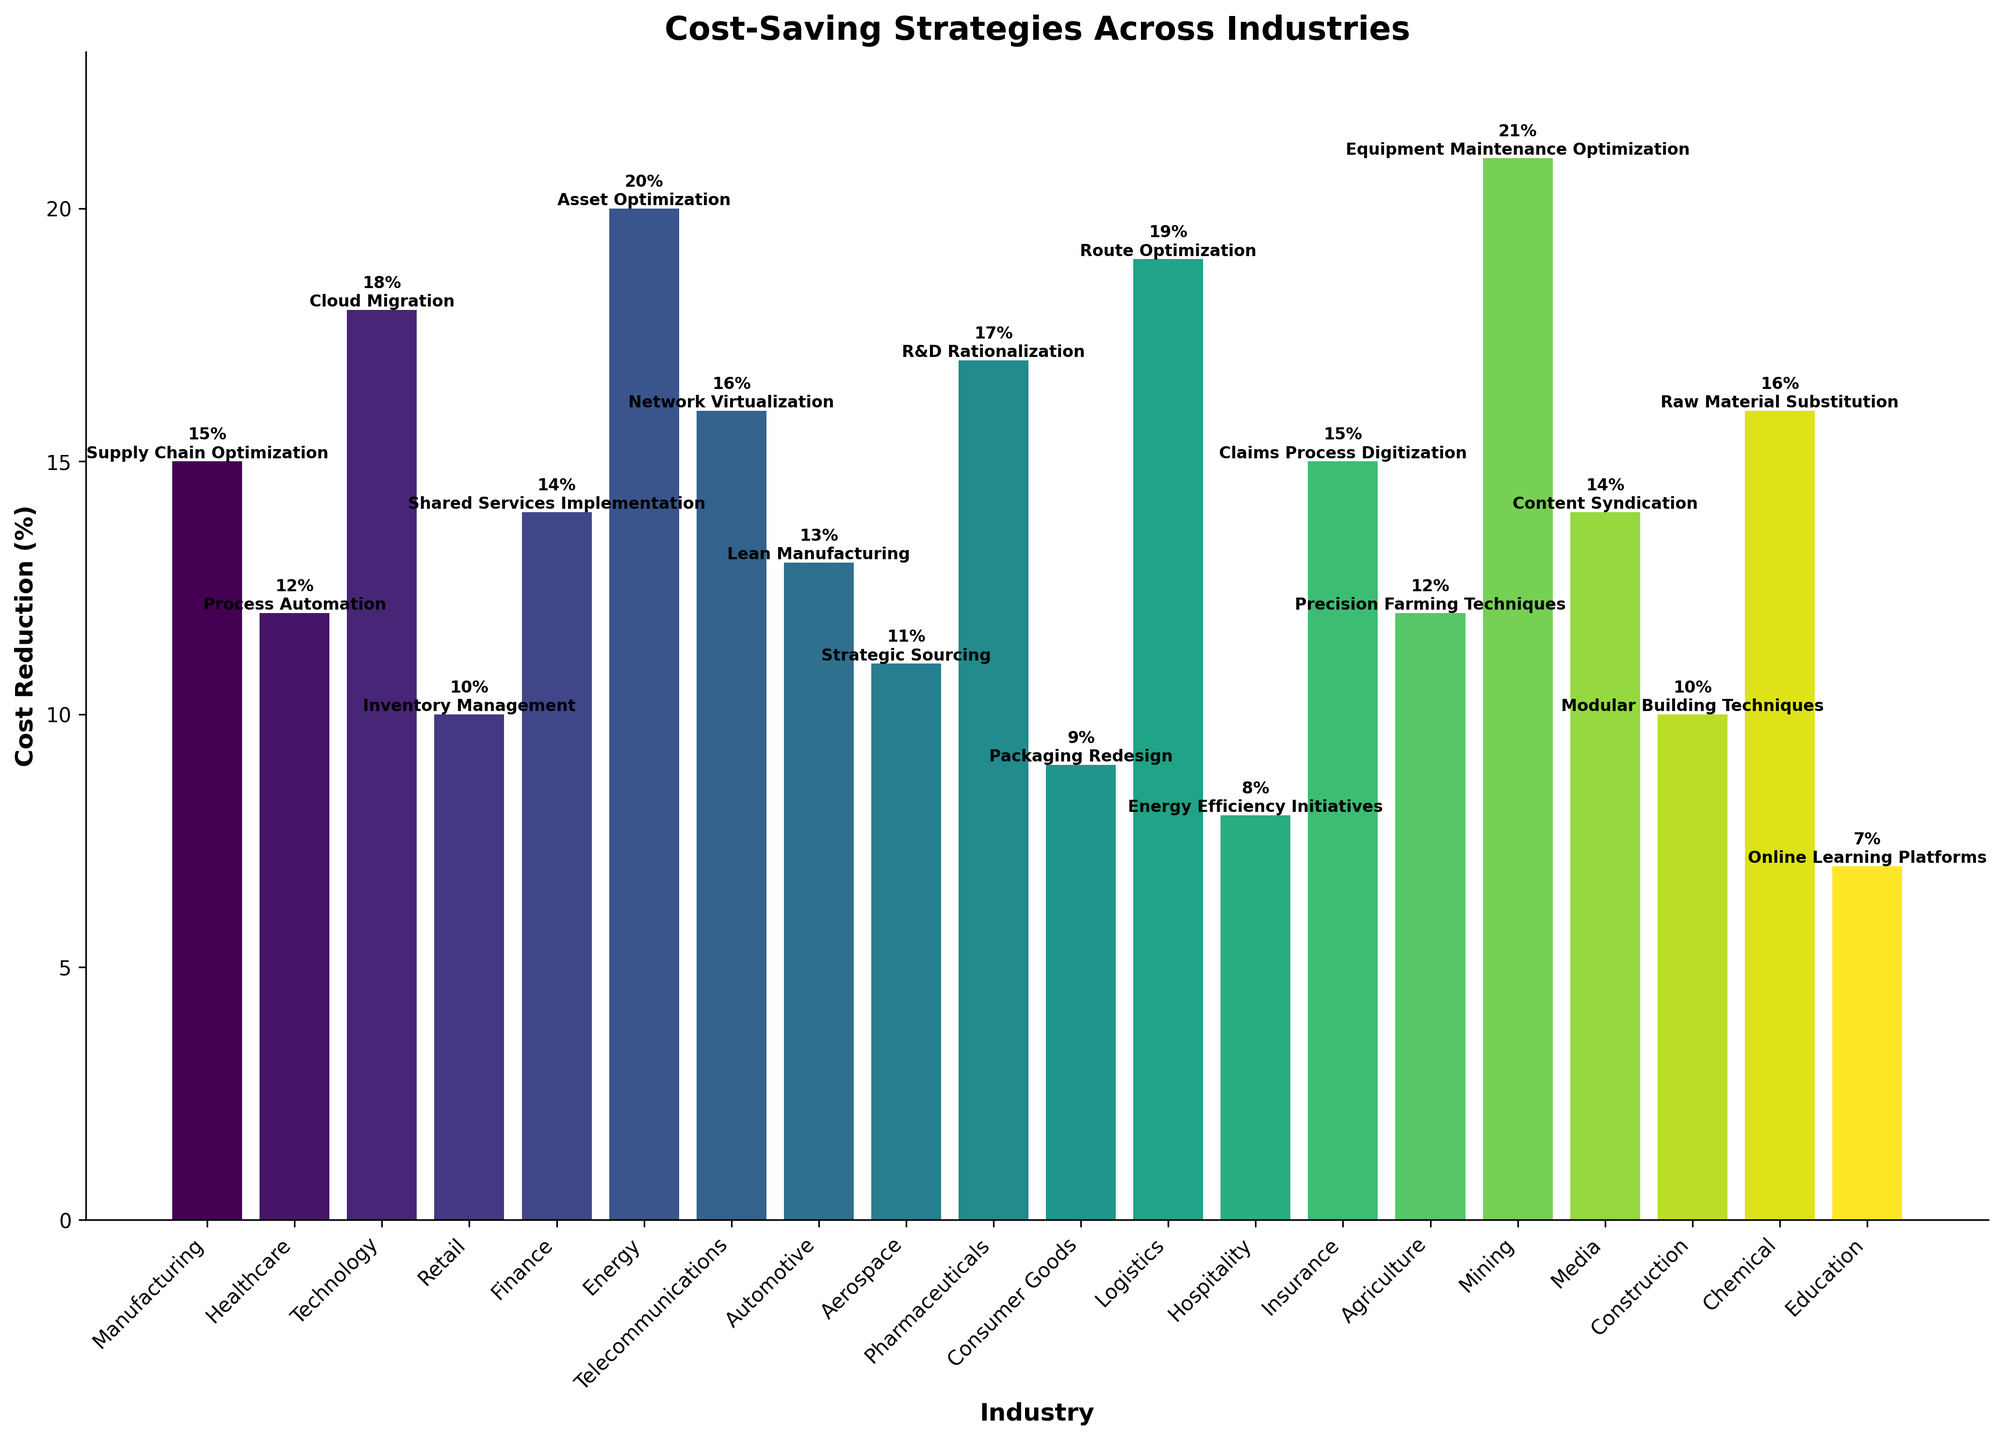What's the highest cost reduction achieved and which industry implemented it? Scan the heights of the bars and identify the tallest one; the tallest bar represents the highest cost reduction. Correspondingly, identify the industry linked to this bar.
Answer: Mining, 21% Which industry has the lowest cost reduction and what strategy did it implement? Identify the shortest bar and its corresponding label. The strategy is indicated by the text on the bar.
Answer: Education, Online Learning Platforms By how much does the cost reduction in Technology exceed the cost reduction in Retail? Locate the bars representing Technology and Retail, note their heights (18% and 10% respectively), and subtract the lower from the higher value.
Answer: 8% Are there any industries that achieved the same percentage cost reduction? If so, which ones? Scan the heights of the bars to identify equal heights and then list the corresponding industries.
Answer: Manufacturing and Insurance both achieved 15%, Healthcare and Agriculture both achieved 12%, Telecommunications and Chemical both achieved 16%, Finance and Media both achieved 14% Which industries saw a cost reduction greater than 15%? Identify all bars taller than the one representing 15% cost reduction and list the corresponding industries.
Answer: Technology, Energy, Telecommunications, Pharmaceuticals, Logistics, Mining What is the total cost reduction percentage if Manufacturing, Finance, and Automotive were combined? Note the cost reductions for these industries (15%, 14%, and 13% respectively) and sum these values.
Answer: 42% How many industries achieved a cost reduction below 10%? Count the number of bars that do not reach the 10% height mark.
Answer: 2 What strategy did the Energy industry implement and what was its cost reduction percentage? Identify the bar labeled 'Energy' and read its height and text description.
Answer: Asset Optimization, 20% What is the average cost reduction percentage across all industries shown? Sum all the cost reduction percentages and divide by the number of industries. (15+12+18+10+14+20+16+13+11+17+9+19+8+15+12+21+14+10+16+7)/20.
Answer: 13.75% List the top three industries with the highest cost reductions and their respective strategies. Identify the three tallest bars and list the corresponding industries and their strategies.
Answer: Mining (Equipment Maintenance Optimization), Energy (Asset Optimization), Logistics (Route Optimization) 